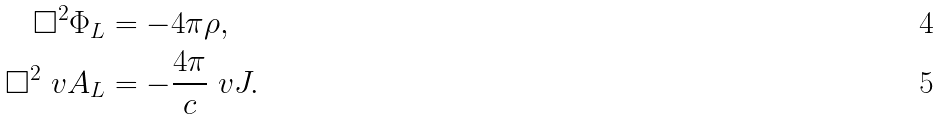Convert formula to latex. <formula><loc_0><loc_0><loc_500><loc_500>\Box ^ { 2 } \Phi _ { L } & = - 4 \pi \rho , \\ \Box ^ { 2 } \ v A _ { L } & = - \frac { 4 \pi } { c } \ v J .</formula> 